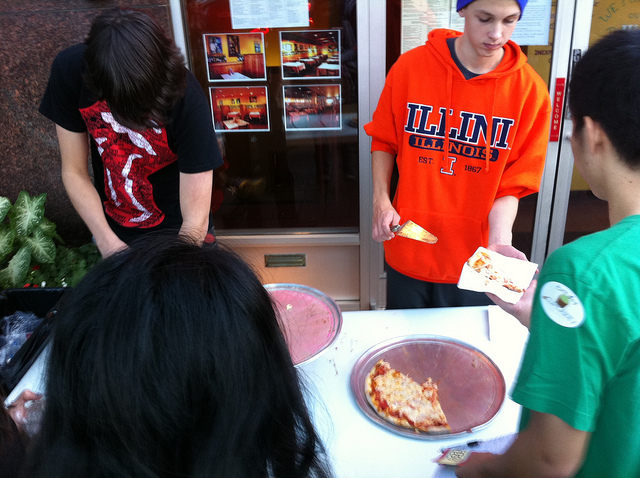<image>What school does the red shirt depict? I am not sure about the school the red shirt depict. It can be 'illini' or 'illinois university'. What school does the red shirt depict? I am not sure which school the red shirt depicts. It can be either 'illini' or 'illinois university'. 